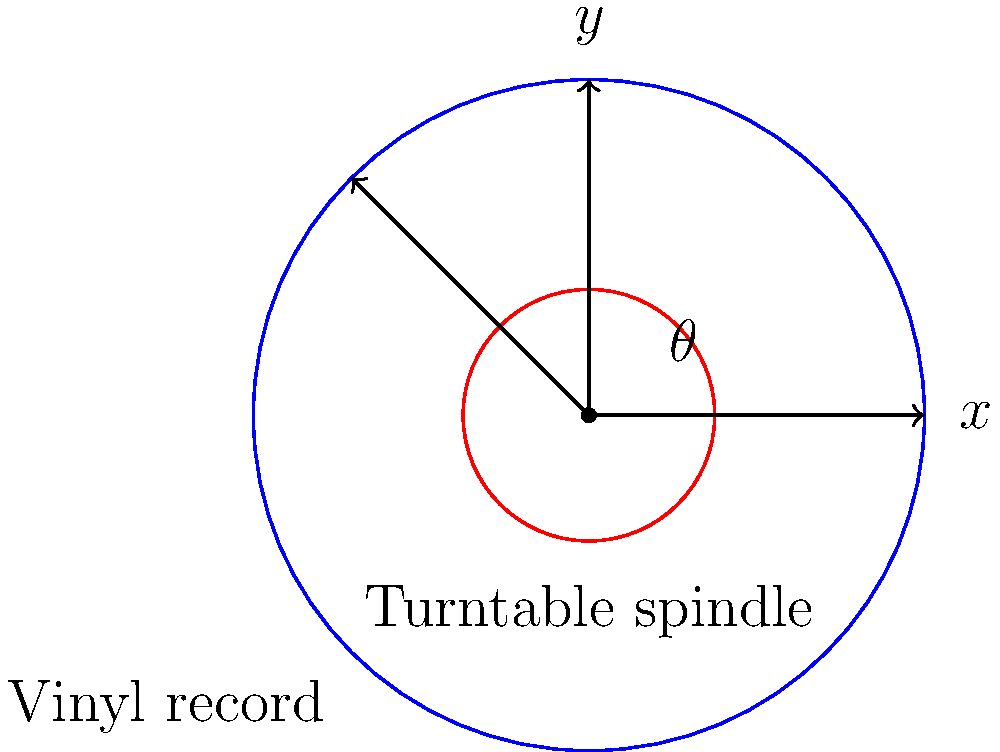As a pop culture enthusiast, you're exploring the physics of vinyl records. A standard 12-inch vinyl record rotates at 33 1/3 revolutions per minute (RPM) on a turntable. If a point on the edge of the record starts at position $(4,0)$ on the coordinate plane, what will be its $(x,y)$ coordinates after 0.3 seconds? Round your answer to two decimal places. Let's approach this step-by-step:

1) First, we need to calculate how much the record rotates in 0.3 seconds:
   - 33 1/3 RPM = 33.33 rotations per minute
   - In one minute, the record rotates 360° × 33.33 = 12,000°
   - In one second, it rotates 12,000° ÷ 60 = 200°
   - In 0.3 seconds, it rotates 200° × 0.3 = 60°

2) Now we know that after 0.3 seconds, the point has rotated 60° counterclockwise from its starting position.

3) To find the new coordinates, we can use trigonometric functions:
   $x = r \cos(\theta)$
   $y = r \sin(\theta)$
   where $r$ is the radius (4 in this case) and $\theta$ is the angle in radians.

4) We need to convert 60° to radians:
   60° × (π/180°) = π/3 radians

5) Now we can calculate:
   $x = 4 \cos(π/3) = 4 × 0.5 = 2$
   $y = 4 \sin(π/3) = 4 × (\sqrt{3}/2) ≈ 3.46$

6) Rounding to two decimal places:
   $x ≈ 2.00$
   $y ≈ 3.46$
Answer: $(2.00, 3.46)$ 